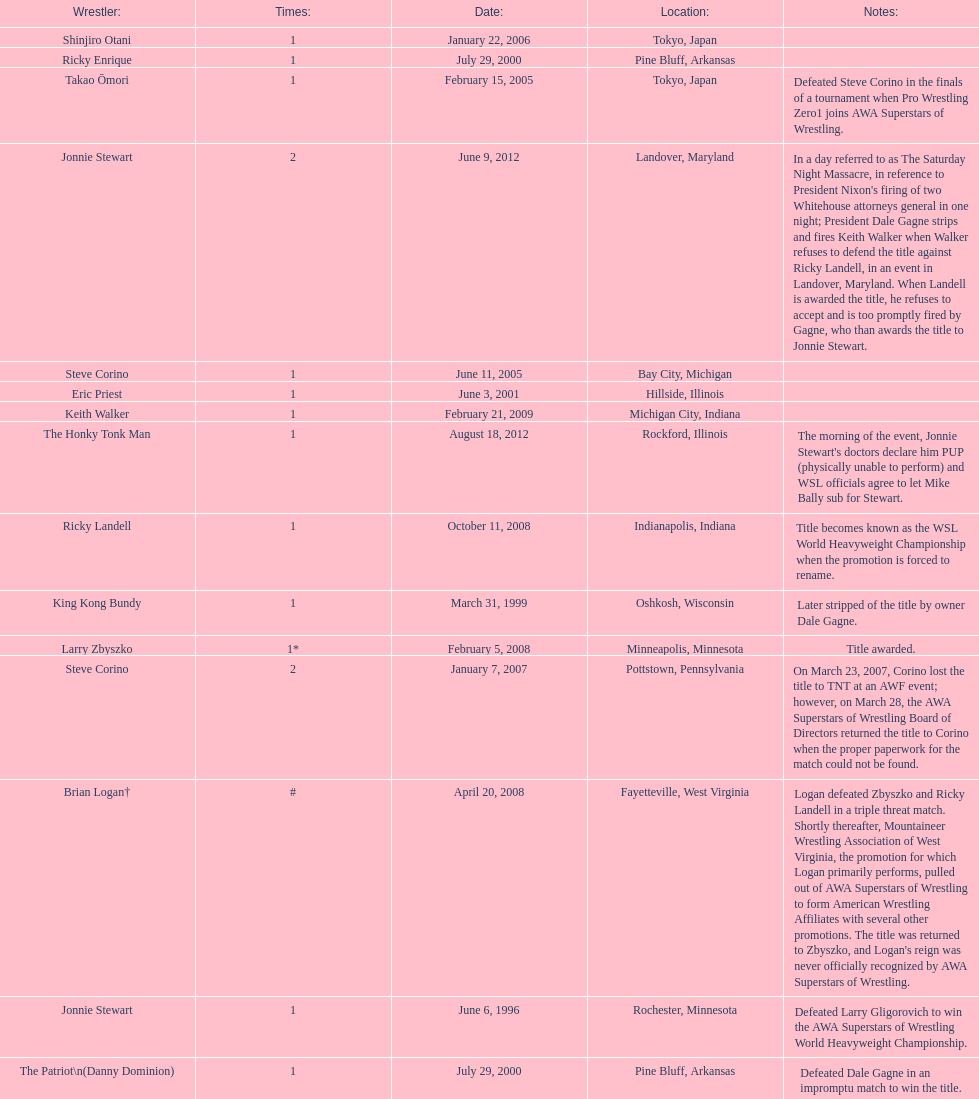What are the number of matches that happened in japan? 5. 